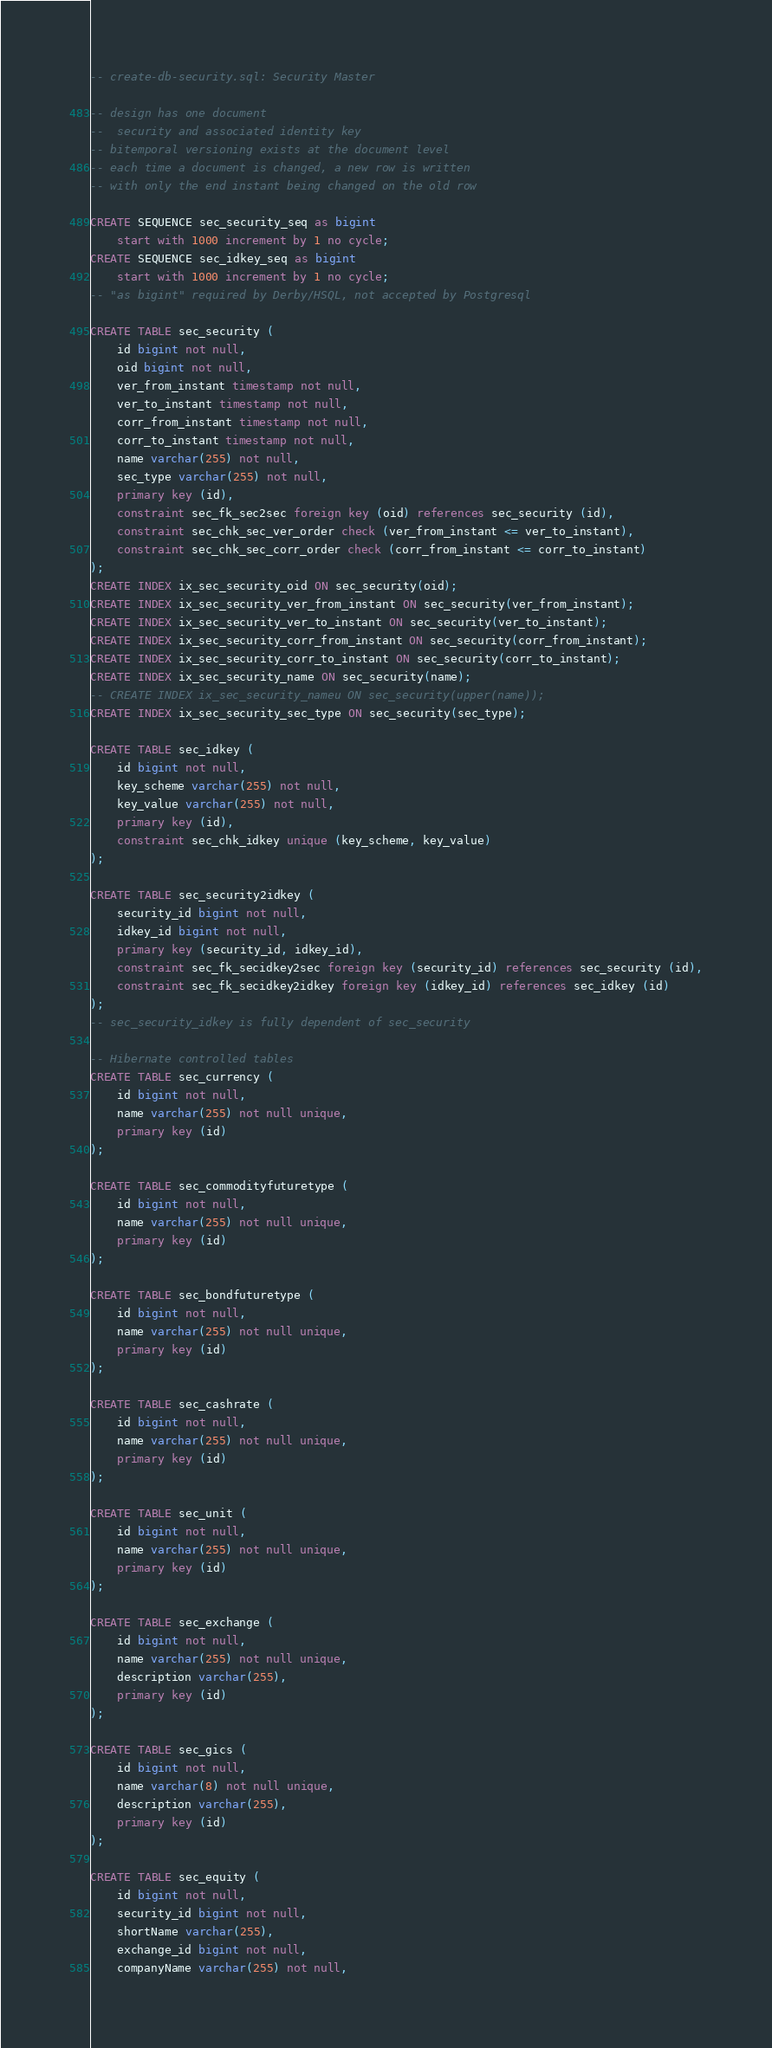<code> <loc_0><loc_0><loc_500><loc_500><_SQL_>
-- create-db-security.sql: Security Master

-- design has one document
--  security and associated identity key
-- bitemporal versioning exists at the document level
-- each time a document is changed, a new row is written
-- with only the end instant being changed on the old row

CREATE SEQUENCE sec_security_seq as bigint
    start with 1000 increment by 1 no cycle;
CREATE SEQUENCE sec_idkey_seq as bigint
    start with 1000 increment by 1 no cycle;
-- "as bigint" required by Derby/HSQL, not accepted by Postgresql

CREATE TABLE sec_security (
    id bigint not null,
    oid bigint not null,
    ver_from_instant timestamp not null,
    ver_to_instant timestamp not null,
    corr_from_instant timestamp not null,
    corr_to_instant timestamp not null,
    name varchar(255) not null,
    sec_type varchar(255) not null,
    primary key (id),
    constraint sec_fk_sec2sec foreign key (oid) references sec_security (id),
    constraint sec_chk_sec_ver_order check (ver_from_instant <= ver_to_instant),
    constraint sec_chk_sec_corr_order check (corr_from_instant <= corr_to_instant)
);
CREATE INDEX ix_sec_security_oid ON sec_security(oid);
CREATE INDEX ix_sec_security_ver_from_instant ON sec_security(ver_from_instant);
CREATE INDEX ix_sec_security_ver_to_instant ON sec_security(ver_to_instant);
CREATE INDEX ix_sec_security_corr_from_instant ON sec_security(corr_from_instant);
CREATE INDEX ix_sec_security_corr_to_instant ON sec_security(corr_to_instant);
CREATE INDEX ix_sec_security_name ON sec_security(name);
-- CREATE INDEX ix_sec_security_nameu ON sec_security(upper(name));
CREATE INDEX ix_sec_security_sec_type ON sec_security(sec_type);

CREATE TABLE sec_idkey (
    id bigint not null,
    key_scheme varchar(255) not null,
    key_value varchar(255) not null,
    primary key (id),
    constraint sec_chk_idkey unique (key_scheme, key_value)
);

CREATE TABLE sec_security2idkey (
    security_id bigint not null,
    idkey_id bigint not null,
    primary key (security_id, idkey_id),
    constraint sec_fk_secidkey2sec foreign key (security_id) references sec_security (id),
    constraint sec_fk_secidkey2idkey foreign key (idkey_id) references sec_idkey (id)
);
-- sec_security_idkey is fully dependent of sec_security

-- Hibernate controlled tables
CREATE TABLE sec_currency (
    id bigint not null,
    name varchar(255) not null unique,
    primary key (id)
);

CREATE TABLE sec_commodityfuturetype (
    id bigint not null,
    name varchar(255) not null unique,
    primary key (id)
);

CREATE TABLE sec_bondfuturetype (
    id bigint not null,
    name varchar(255) not null unique,
    primary key (id)
);

CREATE TABLE sec_cashrate (
    id bigint not null,
    name varchar(255) not null unique,
    primary key (id)
);

CREATE TABLE sec_unit (
    id bigint not null,
    name varchar(255) not null unique,
    primary key (id)
);

CREATE TABLE sec_exchange (
    id bigint not null,
    name varchar(255) not null unique,
    description varchar(255),
    primary key (id)
);

CREATE TABLE sec_gics (
    id bigint not null,
    name varchar(8) not null unique,
    description varchar(255),
    primary key (id)
);

CREATE TABLE sec_equity (
    id bigint not null,
    security_id bigint not null,
    shortName varchar(255),
    exchange_id bigint not null,
    companyName varchar(255) not null,</code> 